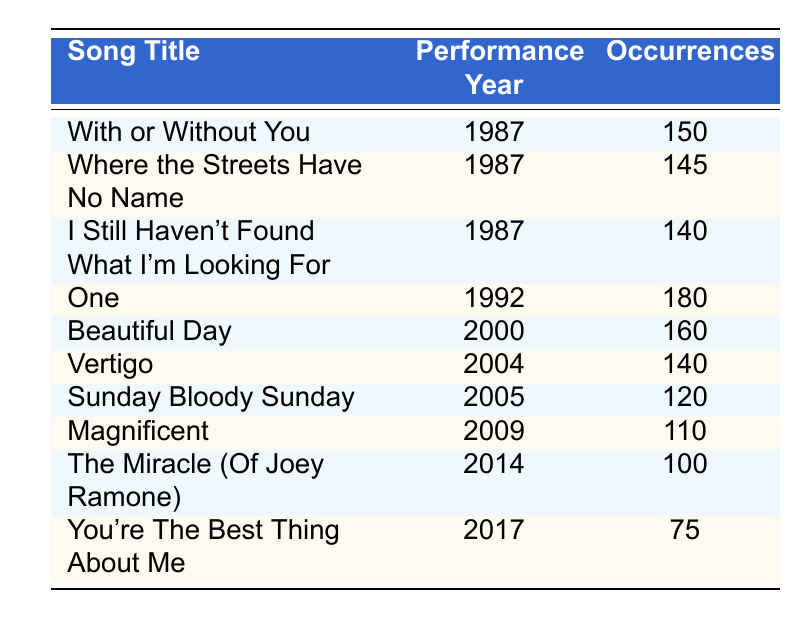What is the song with the highest number of occurrences? By examining the Occurrences column, "One" has the highest value of 180, which is greater than all other entries in that column.
Answer: One In what year did "Beautiful Day" have its first performance according to the table? The Performance Year column shows that "Beautiful Day" was first performed in the year 2000.
Answer: 2000 How many times was "Sunday Bloody Sunday" performed? According to the Occurrences column, "Sunday Bloody Sunday" was performed 120 times.
Answer: 120 Which song had more occurrences: "Vertigo" or "I Still Haven't Found What I'm Looking For"? "Vertigo" had 140 occurrences, while "I Still Haven't Found What I'm Looking For" had 140 occurrences as well. They are equal in this regard.
Answer: They are equal What is the total number of occurrences for songs performed in the year 2005? The only song performed in 2005 is "Sunday Bloody Sunday," which has 120 occurrences. Therefore, the total is 120.
Answer: 120 How many years apart were the performances of "With or Without You" and "You're The Best Thing About Me"? "With or Without You" was performed in 1987, and "You're The Best Thing About Me" in 2017, which is a difference of 30 years.
Answer: 30 years Is "The Miracle (Of Joey Ramone)" performed more frequently than "Magnificent"? "The Miracle (Of Joey Ramone)" had 100 occurrences while "Magnificent" had 110 occurrences. Therefore, "Magnificent" was performed more frequently.
Answer: No What is the average number of occurrences for all songs performed in the 1980s? The only songs from the 1980s are "With or Without You," "Where the Streets Have No Name," and "I Still Haven't Found What I'm Looking For," with occurrences of 150, 145, and 140 respectively. Their total is 435, and the average is 435/3 = 145.
Answer: 145 How many songs were performed in the year 2014 or later? The songs in 2014 or later are "The Miracle (Of Joey Ramone)," "You're The Best Thing About Me," and no others, making a total of 2 songs.
Answer: 2 